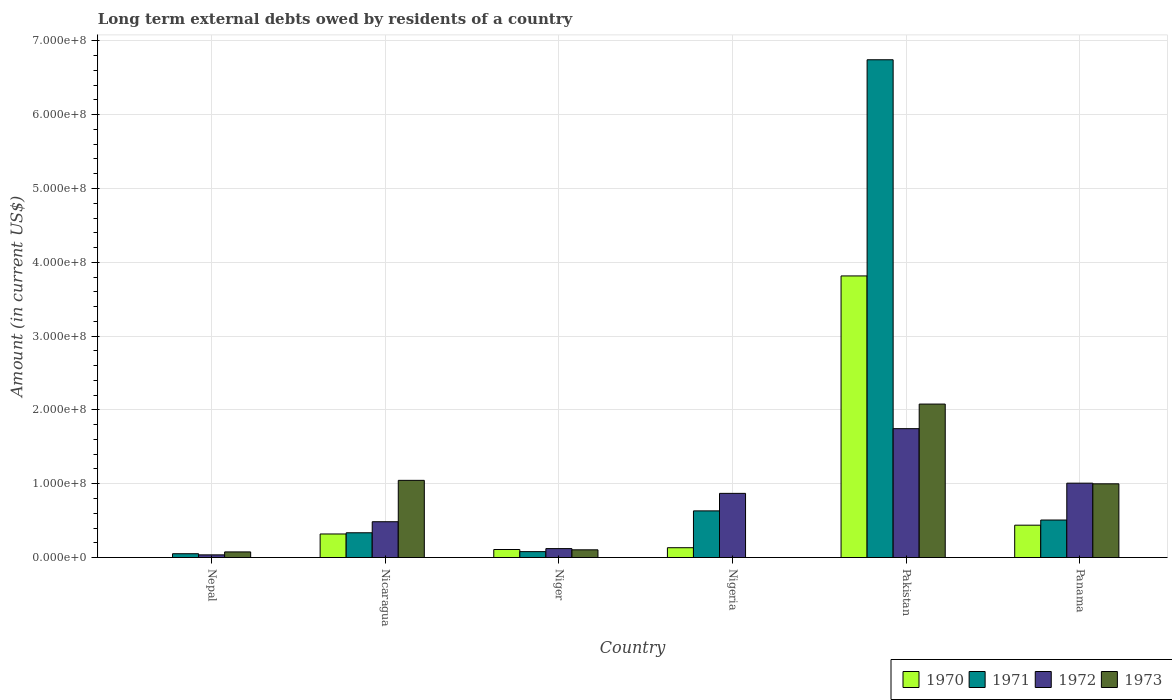How many different coloured bars are there?
Make the answer very short. 4. How many groups of bars are there?
Keep it short and to the point. 6. Are the number of bars per tick equal to the number of legend labels?
Keep it short and to the point. No. How many bars are there on the 1st tick from the left?
Ensure brevity in your answer.  3. How many bars are there on the 2nd tick from the right?
Make the answer very short. 4. What is the label of the 2nd group of bars from the left?
Keep it short and to the point. Nicaragua. In how many cases, is the number of bars for a given country not equal to the number of legend labels?
Provide a succinct answer. 2. What is the amount of long-term external debts owed by residents in 1973 in Nigeria?
Provide a succinct answer. 0. Across all countries, what is the maximum amount of long-term external debts owed by residents in 1973?
Offer a terse response. 2.08e+08. In which country was the amount of long-term external debts owed by residents in 1970 maximum?
Ensure brevity in your answer.  Pakistan. What is the total amount of long-term external debts owed by residents in 1971 in the graph?
Give a very brief answer. 8.35e+08. What is the difference between the amount of long-term external debts owed by residents in 1970 in Niger and that in Nigeria?
Your response must be concise. -2.44e+06. What is the difference between the amount of long-term external debts owed by residents in 1972 in Nepal and the amount of long-term external debts owed by residents in 1973 in Niger?
Offer a terse response. -6.84e+06. What is the average amount of long-term external debts owed by residents in 1973 per country?
Your answer should be compact. 7.17e+07. What is the difference between the amount of long-term external debts owed by residents of/in 1972 and amount of long-term external debts owed by residents of/in 1970 in Niger?
Your answer should be very brief. 1.23e+06. In how many countries, is the amount of long-term external debts owed by residents in 1971 greater than 380000000 US$?
Provide a succinct answer. 1. What is the ratio of the amount of long-term external debts owed by residents in 1972 in Nepal to that in Nigeria?
Make the answer very short. 0.04. Is the amount of long-term external debts owed by residents in 1973 in Nepal less than that in Pakistan?
Provide a succinct answer. Yes. Is the difference between the amount of long-term external debts owed by residents in 1972 in Nicaragua and Pakistan greater than the difference between the amount of long-term external debts owed by residents in 1970 in Nicaragua and Pakistan?
Provide a succinct answer. Yes. What is the difference between the highest and the second highest amount of long-term external debts owed by residents in 1970?
Offer a very short reply. 3.50e+08. What is the difference between the highest and the lowest amount of long-term external debts owed by residents in 1970?
Your answer should be compact. 3.82e+08. In how many countries, is the amount of long-term external debts owed by residents in 1970 greater than the average amount of long-term external debts owed by residents in 1970 taken over all countries?
Give a very brief answer. 1. Is it the case that in every country, the sum of the amount of long-term external debts owed by residents in 1970 and amount of long-term external debts owed by residents in 1973 is greater than the sum of amount of long-term external debts owed by residents in 1971 and amount of long-term external debts owed by residents in 1972?
Make the answer very short. No. Is it the case that in every country, the sum of the amount of long-term external debts owed by residents in 1970 and amount of long-term external debts owed by residents in 1972 is greater than the amount of long-term external debts owed by residents in 1971?
Provide a succinct answer. No. How many bars are there?
Give a very brief answer. 22. How many countries are there in the graph?
Make the answer very short. 6. What is the difference between two consecutive major ticks on the Y-axis?
Give a very brief answer. 1.00e+08. Are the values on the major ticks of Y-axis written in scientific E-notation?
Your answer should be very brief. Yes. Where does the legend appear in the graph?
Keep it short and to the point. Bottom right. How many legend labels are there?
Make the answer very short. 4. How are the legend labels stacked?
Your answer should be very brief. Horizontal. What is the title of the graph?
Offer a terse response. Long term external debts owed by residents of a country. Does "2003" appear as one of the legend labels in the graph?
Your answer should be very brief. No. What is the label or title of the X-axis?
Offer a very short reply. Country. What is the Amount (in current US$) in 1970 in Nepal?
Make the answer very short. 0. What is the Amount (in current US$) of 1971 in Nepal?
Offer a terse response. 5.15e+06. What is the Amount (in current US$) in 1972 in Nepal?
Offer a very short reply. 3.60e+06. What is the Amount (in current US$) of 1973 in Nepal?
Provide a short and direct response. 7.60e+06. What is the Amount (in current US$) of 1970 in Nicaragua?
Your answer should be compact. 3.19e+07. What is the Amount (in current US$) of 1971 in Nicaragua?
Give a very brief answer. 3.35e+07. What is the Amount (in current US$) in 1972 in Nicaragua?
Keep it short and to the point. 4.85e+07. What is the Amount (in current US$) of 1973 in Nicaragua?
Offer a very short reply. 1.05e+08. What is the Amount (in current US$) of 1970 in Niger?
Provide a succinct answer. 1.09e+07. What is the Amount (in current US$) in 1971 in Niger?
Provide a succinct answer. 8.00e+06. What is the Amount (in current US$) of 1972 in Niger?
Offer a terse response. 1.21e+07. What is the Amount (in current US$) in 1973 in Niger?
Provide a short and direct response. 1.04e+07. What is the Amount (in current US$) of 1970 in Nigeria?
Offer a very short reply. 1.33e+07. What is the Amount (in current US$) of 1971 in Nigeria?
Keep it short and to the point. 6.32e+07. What is the Amount (in current US$) of 1972 in Nigeria?
Your answer should be compact. 8.69e+07. What is the Amount (in current US$) in 1970 in Pakistan?
Provide a succinct answer. 3.82e+08. What is the Amount (in current US$) of 1971 in Pakistan?
Give a very brief answer. 6.74e+08. What is the Amount (in current US$) in 1972 in Pakistan?
Give a very brief answer. 1.75e+08. What is the Amount (in current US$) of 1973 in Pakistan?
Offer a very short reply. 2.08e+08. What is the Amount (in current US$) of 1970 in Panama?
Your answer should be very brief. 4.38e+07. What is the Amount (in current US$) in 1971 in Panama?
Keep it short and to the point. 5.08e+07. What is the Amount (in current US$) of 1972 in Panama?
Ensure brevity in your answer.  1.01e+08. What is the Amount (in current US$) in 1973 in Panama?
Provide a succinct answer. 9.99e+07. Across all countries, what is the maximum Amount (in current US$) of 1970?
Offer a very short reply. 3.82e+08. Across all countries, what is the maximum Amount (in current US$) of 1971?
Offer a very short reply. 6.74e+08. Across all countries, what is the maximum Amount (in current US$) in 1972?
Give a very brief answer. 1.75e+08. Across all countries, what is the maximum Amount (in current US$) of 1973?
Make the answer very short. 2.08e+08. Across all countries, what is the minimum Amount (in current US$) in 1970?
Your response must be concise. 0. Across all countries, what is the minimum Amount (in current US$) of 1971?
Offer a very short reply. 5.15e+06. Across all countries, what is the minimum Amount (in current US$) in 1972?
Make the answer very short. 3.60e+06. What is the total Amount (in current US$) in 1970 in the graph?
Provide a short and direct response. 4.81e+08. What is the total Amount (in current US$) in 1971 in the graph?
Make the answer very short. 8.35e+08. What is the total Amount (in current US$) in 1972 in the graph?
Your answer should be very brief. 4.26e+08. What is the total Amount (in current US$) in 1973 in the graph?
Make the answer very short. 4.30e+08. What is the difference between the Amount (in current US$) of 1971 in Nepal and that in Nicaragua?
Your response must be concise. -2.84e+07. What is the difference between the Amount (in current US$) in 1972 in Nepal and that in Nicaragua?
Make the answer very short. -4.49e+07. What is the difference between the Amount (in current US$) in 1973 in Nepal and that in Nicaragua?
Ensure brevity in your answer.  -9.70e+07. What is the difference between the Amount (in current US$) of 1971 in Nepal and that in Niger?
Ensure brevity in your answer.  -2.85e+06. What is the difference between the Amount (in current US$) of 1972 in Nepal and that in Niger?
Provide a succinct answer. -8.48e+06. What is the difference between the Amount (in current US$) of 1973 in Nepal and that in Niger?
Offer a terse response. -2.84e+06. What is the difference between the Amount (in current US$) in 1971 in Nepal and that in Nigeria?
Give a very brief answer. -5.81e+07. What is the difference between the Amount (in current US$) of 1972 in Nepal and that in Nigeria?
Provide a succinct answer. -8.33e+07. What is the difference between the Amount (in current US$) of 1971 in Nepal and that in Pakistan?
Your answer should be very brief. -6.69e+08. What is the difference between the Amount (in current US$) of 1972 in Nepal and that in Pakistan?
Keep it short and to the point. -1.71e+08. What is the difference between the Amount (in current US$) of 1973 in Nepal and that in Pakistan?
Give a very brief answer. -2.00e+08. What is the difference between the Amount (in current US$) in 1971 in Nepal and that in Panama?
Provide a succinct answer. -4.57e+07. What is the difference between the Amount (in current US$) of 1972 in Nepal and that in Panama?
Provide a succinct answer. -9.72e+07. What is the difference between the Amount (in current US$) in 1973 in Nepal and that in Panama?
Your answer should be very brief. -9.23e+07. What is the difference between the Amount (in current US$) of 1970 in Nicaragua and that in Niger?
Offer a very short reply. 2.10e+07. What is the difference between the Amount (in current US$) of 1971 in Nicaragua and that in Niger?
Your answer should be compact. 2.55e+07. What is the difference between the Amount (in current US$) of 1972 in Nicaragua and that in Niger?
Ensure brevity in your answer.  3.64e+07. What is the difference between the Amount (in current US$) of 1973 in Nicaragua and that in Niger?
Provide a short and direct response. 9.41e+07. What is the difference between the Amount (in current US$) of 1970 in Nicaragua and that in Nigeria?
Your response must be concise. 1.86e+07. What is the difference between the Amount (in current US$) of 1971 in Nicaragua and that in Nigeria?
Your answer should be very brief. -2.97e+07. What is the difference between the Amount (in current US$) in 1972 in Nicaragua and that in Nigeria?
Provide a short and direct response. -3.84e+07. What is the difference between the Amount (in current US$) of 1970 in Nicaragua and that in Pakistan?
Your answer should be compact. -3.50e+08. What is the difference between the Amount (in current US$) in 1971 in Nicaragua and that in Pakistan?
Provide a short and direct response. -6.41e+08. What is the difference between the Amount (in current US$) in 1972 in Nicaragua and that in Pakistan?
Your answer should be very brief. -1.26e+08. What is the difference between the Amount (in current US$) of 1973 in Nicaragua and that in Pakistan?
Offer a very short reply. -1.03e+08. What is the difference between the Amount (in current US$) in 1970 in Nicaragua and that in Panama?
Offer a very short reply. -1.19e+07. What is the difference between the Amount (in current US$) in 1971 in Nicaragua and that in Panama?
Ensure brevity in your answer.  -1.73e+07. What is the difference between the Amount (in current US$) in 1972 in Nicaragua and that in Panama?
Ensure brevity in your answer.  -5.23e+07. What is the difference between the Amount (in current US$) of 1973 in Nicaragua and that in Panama?
Give a very brief answer. 4.71e+06. What is the difference between the Amount (in current US$) in 1970 in Niger and that in Nigeria?
Provide a succinct answer. -2.44e+06. What is the difference between the Amount (in current US$) in 1971 in Niger and that in Nigeria?
Give a very brief answer. -5.52e+07. What is the difference between the Amount (in current US$) of 1972 in Niger and that in Nigeria?
Your answer should be very brief. -7.48e+07. What is the difference between the Amount (in current US$) of 1970 in Niger and that in Pakistan?
Ensure brevity in your answer.  -3.71e+08. What is the difference between the Amount (in current US$) of 1971 in Niger and that in Pakistan?
Offer a terse response. -6.66e+08. What is the difference between the Amount (in current US$) of 1972 in Niger and that in Pakistan?
Offer a very short reply. -1.63e+08. What is the difference between the Amount (in current US$) in 1973 in Niger and that in Pakistan?
Your answer should be compact. -1.97e+08. What is the difference between the Amount (in current US$) of 1970 in Niger and that in Panama?
Make the answer very short. -3.30e+07. What is the difference between the Amount (in current US$) of 1971 in Niger and that in Panama?
Offer a terse response. -4.28e+07. What is the difference between the Amount (in current US$) of 1972 in Niger and that in Panama?
Make the answer very short. -8.87e+07. What is the difference between the Amount (in current US$) of 1973 in Niger and that in Panama?
Offer a terse response. -8.94e+07. What is the difference between the Amount (in current US$) of 1970 in Nigeria and that in Pakistan?
Give a very brief answer. -3.68e+08. What is the difference between the Amount (in current US$) of 1971 in Nigeria and that in Pakistan?
Ensure brevity in your answer.  -6.11e+08. What is the difference between the Amount (in current US$) of 1972 in Nigeria and that in Pakistan?
Your answer should be compact. -8.77e+07. What is the difference between the Amount (in current US$) of 1970 in Nigeria and that in Panama?
Your answer should be very brief. -3.05e+07. What is the difference between the Amount (in current US$) of 1971 in Nigeria and that in Panama?
Make the answer very short. 1.24e+07. What is the difference between the Amount (in current US$) in 1972 in Nigeria and that in Panama?
Your answer should be very brief. -1.38e+07. What is the difference between the Amount (in current US$) in 1970 in Pakistan and that in Panama?
Keep it short and to the point. 3.38e+08. What is the difference between the Amount (in current US$) in 1971 in Pakistan and that in Panama?
Provide a short and direct response. 6.24e+08. What is the difference between the Amount (in current US$) of 1972 in Pakistan and that in Panama?
Keep it short and to the point. 7.38e+07. What is the difference between the Amount (in current US$) of 1973 in Pakistan and that in Panama?
Provide a succinct answer. 1.08e+08. What is the difference between the Amount (in current US$) in 1971 in Nepal and the Amount (in current US$) in 1972 in Nicaragua?
Provide a succinct answer. -4.34e+07. What is the difference between the Amount (in current US$) in 1971 in Nepal and the Amount (in current US$) in 1973 in Nicaragua?
Your answer should be compact. -9.94e+07. What is the difference between the Amount (in current US$) in 1972 in Nepal and the Amount (in current US$) in 1973 in Nicaragua?
Your response must be concise. -1.01e+08. What is the difference between the Amount (in current US$) of 1971 in Nepal and the Amount (in current US$) of 1972 in Niger?
Your answer should be compact. -6.94e+06. What is the difference between the Amount (in current US$) of 1971 in Nepal and the Amount (in current US$) of 1973 in Niger?
Your response must be concise. -5.30e+06. What is the difference between the Amount (in current US$) in 1972 in Nepal and the Amount (in current US$) in 1973 in Niger?
Provide a short and direct response. -6.84e+06. What is the difference between the Amount (in current US$) in 1971 in Nepal and the Amount (in current US$) in 1972 in Nigeria?
Your answer should be compact. -8.18e+07. What is the difference between the Amount (in current US$) in 1971 in Nepal and the Amount (in current US$) in 1972 in Pakistan?
Ensure brevity in your answer.  -1.69e+08. What is the difference between the Amount (in current US$) in 1971 in Nepal and the Amount (in current US$) in 1973 in Pakistan?
Make the answer very short. -2.03e+08. What is the difference between the Amount (in current US$) of 1972 in Nepal and the Amount (in current US$) of 1973 in Pakistan?
Keep it short and to the point. -2.04e+08. What is the difference between the Amount (in current US$) of 1971 in Nepal and the Amount (in current US$) of 1972 in Panama?
Your answer should be very brief. -9.56e+07. What is the difference between the Amount (in current US$) of 1971 in Nepal and the Amount (in current US$) of 1973 in Panama?
Keep it short and to the point. -9.47e+07. What is the difference between the Amount (in current US$) of 1972 in Nepal and the Amount (in current US$) of 1973 in Panama?
Your answer should be very brief. -9.63e+07. What is the difference between the Amount (in current US$) in 1970 in Nicaragua and the Amount (in current US$) in 1971 in Niger?
Keep it short and to the point. 2.39e+07. What is the difference between the Amount (in current US$) of 1970 in Nicaragua and the Amount (in current US$) of 1972 in Niger?
Offer a very short reply. 1.98e+07. What is the difference between the Amount (in current US$) in 1970 in Nicaragua and the Amount (in current US$) in 1973 in Niger?
Make the answer very short. 2.15e+07. What is the difference between the Amount (in current US$) of 1971 in Nicaragua and the Amount (in current US$) of 1972 in Niger?
Your answer should be compact. 2.14e+07. What is the difference between the Amount (in current US$) of 1971 in Nicaragua and the Amount (in current US$) of 1973 in Niger?
Ensure brevity in your answer.  2.31e+07. What is the difference between the Amount (in current US$) of 1972 in Nicaragua and the Amount (in current US$) of 1973 in Niger?
Provide a short and direct response. 3.81e+07. What is the difference between the Amount (in current US$) in 1970 in Nicaragua and the Amount (in current US$) in 1971 in Nigeria?
Make the answer very short. -3.13e+07. What is the difference between the Amount (in current US$) in 1970 in Nicaragua and the Amount (in current US$) in 1972 in Nigeria?
Offer a terse response. -5.50e+07. What is the difference between the Amount (in current US$) of 1971 in Nicaragua and the Amount (in current US$) of 1972 in Nigeria?
Make the answer very short. -5.34e+07. What is the difference between the Amount (in current US$) of 1970 in Nicaragua and the Amount (in current US$) of 1971 in Pakistan?
Provide a succinct answer. -6.43e+08. What is the difference between the Amount (in current US$) in 1970 in Nicaragua and the Amount (in current US$) in 1972 in Pakistan?
Your response must be concise. -1.43e+08. What is the difference between the Amount (in current US$) of 1970 in Nicaragua and the Amount (in current US$) of 1973 in Pakistan?
Provide a short and direct response. -1.76e+08. What is the difference between the Amount (in current US$) of 1971 in Nicaragua and the Amount (in current US$) of 1972 in Pakistan?
Keep it short and to the point. -1.41e+08. What is the difference between the Amount (in current US$) of 1971 in Nicaragua and the Amount (in current US$) of 1973 in Pakistan?
Keep it short and to the point. -1.74e+08. What is the difference between the Amount (in current US$) of 1972 in Nicaragua and the Amount (in current US$) of 1973 in Pakistan?
Make the answer very short. -1.59e+08. What is the difference between the Amount (in current US$) in 1970 in Nicaragua and the Amount (in current US$) in 1971 in Panama?
Provide a succinct answer. -1.89e+07. What is the difference between the Amount (in current US$) of 1970 in Nicaragua and the Amount (in current US$) of 1972 in Panama?
Make the answer very short. -6.89e+07. What is the difference between the Amount (in current US$) of 1970 in Nicaragua and the Amount (in current US$) of 1973 in Panama?
Your response must be concise. -6.80e+07. What is the difference between the Amount (in current US$) in 1971 in Nicaragua and the Amount (in current US$) in 1972 in Panama?
Give a very brief answer. -6.72e+07. What is the difference between the Amount (in current US$) in 1971 in Nicaragua and the Amount (in current US$) in 1973 in Panama?
Offer a terse response. -6.63e+07. What is the difference between the Amount (in current US$) of 1972 in Nicaragua and the Amount (in current US$) of 1973 in Panama?
Offer a terse response. -5.14e+07. What is the difference between the Amount (in current US$) of 1970 in Niger and the Amount (in current US$) of 1971 in Nigeria?
Keep it short and to the point. -5.24e+07. What is the difference between the Amount (in current US$) in 1970 in Niger and the Amount (in current US$) in 1972 in Nigeria?
Your response must be concise. -7.61e+07. What is the difference between the Amount (in current US$) in 1971 in Niger and the Amount (in current US$) in 1972 in Nigeria?
Your answer should be very brief. -7.89e+07. What is the difference between the Amount (in current US$) of 1970 in Niger and the Amount (in current US$) of 1971 in Pakistan?
Your response must be concise. -6.64e+08. What is the difference between the Amount (in current US$) in 1970 in Niger and the Amount (in current US$) in 1972 in Pakistan?
Ensure brevity in your answer.  -1.64e+08. What is the difference between the Amount (in current US$) of 1970 in Niger and the Amount (in current US$) of 1973 in Pakistan?
Keep it short and to the point. -1.97e+08. What is the difference between the Amount (in current US$) of 1971 in Niger and the Amount (in current US$) of 1972 in Pakistan?
Offer a terse response. -1.67e+08. What is the difference between the Amount (in current US$) in 1971 in Niger and the Amount (in current US$) in 1973 in Pakistan?
Provide a short and direct response. -2.00e+08. What is the difference between the Amount (in current US$) of 1972 in Niger and the Amount (in current US$) of 1973 in Pakistan?
Provide a short and direct response. -1.96e+08. What is the difference between the Amount (in current US$) of 1970 in Niger and the Amount (in current US$) of 1971 in Panama?
Ensure brevity in your answer.  -4.00e+07. What is the difference between the Amount (in current US$) of 1970 in Niger and the Amount (in current US$) of 1972 in Panama?
Offer a terse response. -8.99e+07. What is the difference between the Amount (in current US$) of 1970 in Niger and the Amount (in current US$) of 1973 in Panama?
Offer a very short reply. -8.90e+07. What is the difference between the Amount (in current US$) of 1971 in Niger and the Amount (in current US$) of 1972 in Panama?
Your response must be concise. -9.28e+07. What is the difference between the Amount (in current US$) in 1971 in Niger and the Amount (in current US$) in 1973 in Panama?
Your answer should be very brief. -9.19e+07. What is the difference between the Amount (in current US$) in 1972 in Niger and the Amount (in current US$) in 1973 in Panama?
Your answer should be very brief. -8.78e+07. What is the difference between the Amount (in current US$) of 1970 in Nigeria and the Amount (in current US$) of 1971 in Pakistan?
Your answer should be very brief. -6.61e+08. What is the difference between the Amount (in current US$) of 1970 in Nigeria and the Amount (in current US$) of 1972 in Pakistan?
Offer a very short reply. -1.61e+08. What is the difference between the Amount (in current US$) of 1970 in Nigeria and the Amount (in current US$) of 1973 in Pakistan?
Make the answer very short. -1.95e+08. What is the difference between the Amount (in current US$) in 1971 in Nigeria and the Amount (in current US$) in 1972 in Pakistan?
Provide a succinct answer. -1.11e+08. What is the difference between the Amount (in current US$) of 1971 in Nigeria and the Amount (in current US$) of 1973 in Pakistan?
Offer a terse response. -1.45e+08. What is the difference between the Amount (in current US$) of 1972 in Nigeria and the Amount (in current US$) of 1973 in Pakistan?
Your answer should be compact. -1.21e+08. What is the difference between the Amount (in current US$) of 1970 in Nigeria and the Amount (in current US$) of 1971 in Panama?
Your answer should be very brief. -3.75e+07. What is the difference between the Amount (in current US$) in 1970 in Nigeria and the Amount (in current US$) in 1972 in Panama?
Provide a succinct answer. -8.75e+07. What is the difference between the Amount (in current US$) of 1970 in Nigeria and the Amount (in current US$) of 1973 in Panama?
Your answer should be very brief. -8.66e+07. What is the difference between the Amount (in current US$) in 1971 in Nigeria and the Amount (in current US$) in 1972 in Panama?
Ensure brevity in your answer.  -3.76e+07. What is the difference between the Amount (in current US$) of 1971 in Nigeria and the Amount (in current US$) of 1973 in Panama?
Provide a short and direct response. -3.67e+07. What is the difference between the Amount (in current US$) in 1972 in Nigeria and the Amount (in current US$) in 1973 in Panama?
Offer a very short reply. -1.29e+07. What is the difference between the Amount (in current US$) of 1970 in Pakistan and the Amount (in current US$) of 1971 in Panama?
Your response must be concise. 3.31e+08. What is the difference between the Amount (in current US$) of 1970 in Pakistan and the Amount (in current US$) of 1972 in Panama?
Make the answer very short. 2.81e+08. What is the difference between the Amount (in current US$) in 1970 in Pakistan and the Amount (in current US$) in 1973 in Panama?
Make the answer very short. 2.82e+08. What is the difference between the Amount (in current US$) of 1971 in Pakistan and the Amount (in current US$) of 1972 in Panama?
Keep it short and to the point. 5.74e+08. What is the difference between the Amount (in current US$) in 1971 in Pakistan and the Amount (in current US$) in 1973 in Panama?
Ensure brevity in your answer.  5.75e+08. What is the difference between the Amount (in current US$) of 1972 in Pakistan and the Amount (in current US$) of 1973 in Panama?
Provide a succinct answer. 7.47e+07. What is the average Amount (in current US$) in 1970 per country?
Your response must be concise. 8.02e+07. What is the average Amount (in current US$) in 1971 per country?
Ensure brevity in your answer.  1.39e+08. What is the average Amount (in current US$) in 1972 per country?
Offer a terse response. 7.11e+07. What is the average Amount (in current US$) in 1973 per country?
Your answer should be very brief. 7.17e+07. What is the difference between the Amount (in current US$) of 1971 and Amount (in current US$) of 1972 in Nepal?
Your answer should be compact. 1.54e+06. What is the difference between the Amount (in current US$) of 1971 and Amount (in current US$) of 1973 in Nepal?
Provide a short and direct response. -2.46e+06. What is the difference between the Amount (in current US$) in 1972 and Amount (in current US$) in 1973 in Nepal?
Offer a terse response. -4.00e+06. What is the difference between the Amount (in current US$) of 1970 and Amount (in current US$) of 1971 in Nicaragua?
Offer a very short reply. -1.63e+06. What is the difference between the Amount (in current US$) of 1970 and Amount (in current US$) of 1972 in Nicaragua?
Provide a succinct answer. -1.66e+07. What is the difference between the Amount (in current US$) of 1970 and Amount (in current US$) of 1973 in Nicaragua?
Offer a very short reply. -7.27e+07. What is the difference between the Amount (in current US$) in 1971 and Amount (in current US$) in 1972 in Nicaragua?
Provide a succinct answer. -1.50e+07. What is the difference between the Amount (in current US$) of 1971 and Amount (in current US$) of 1973 in Nicaragua?
Give a very brief answer. -7.10e+07. What is the difference between the Amount (in current US$) of 1972 and Amount (in current US$) of 1973 in Nicaragua?
Keep it short and to the point. -5.61e+07. What is the difference between the Amount (in current US$) in 1970 and Amount (in current US$) in 1971 in Niger?
Provide a succinct answer. 2.86e+06. What is the difference between the Amount (in current US$) in 1970 and Amount (in current US$) in 1972 in Niger?
Provide a short and direct response. -1.23e+06. What is the difference between the Amount (in current US$) in 1970 and Amount (in current US$) in 1973 in Niger?
Offer a terse response. 4.08e+05. What is the difference between the Amount (in current US$) in 1971 and Amount (in current US$) in 1972 in Niger?
Your answer should be compact. -4.09e+06. What is the difference between the Amount (in current US$) of 1971 and Amount (in current US$) of 1973 in Niger?
Keep it short and to the point. -2.45e+06. What is the difference between the Amount (in current US$) in 1972 and Amount (in current US$) in 1973 in Niger?
Offer a very short reply. 1.64e+06. What is the difference between the Amount (in current US$) of 1970 and Amount (in current US$) of 1971 in Nigeria?
Provide a short and direct response. -4.99e+07. What is the difference between the Amount (in current US$) in 1970 and Amount (in current US$) in 1972 in Nigeria?
Offer a very short reply. -7.36e+07. What is the difference between the Amount (in current US$) of 1971 and Amount (in current US$) of 1972 in Nigeria?
Make the answer very short. -2.37e+07. What is the difference between the Amount (in current US$) of 1970 and Amount (in current US$) of 1971 in Pakistan?
Ensure brevity in your answer.  -2.93e+08. What is the difference between the Amount (in current US$) in 1970 and Amount (in current US$) in 1972 in Pakistan?
Provide a short and direct response. 2.07e+08. What is the difference between the Amount (in current US$) in 1970 and Amount (in current US$) in 1973 in Pakistan?
Keep it short and to the point. 1.74e+08. What is the difference between the Amount (in current US$) of 1971 and Amount (in current US$) of 1972 in Pakistan?
Keep it short and to the point. 5.00e+08. What is the difference between the Amount (in current US$) in 1971 and Amount (in current US$) in 1973 in Pakistan?
Your answer should be compact. 4.67e+08. What is the difference between the Amount (in current US$) of 1972 and Amount (in current US$) of 1973 in Pakistan?
Your answer should be very brief. -3.33e+07. What is the difference between the Amount (in current US$) in 1970 and Amount (in current US$) in 1971 in Panama?
Ensure brevity in your answer.  -6.98e+06. What is the difference between the Amount (in current US$) in 1970 and Amount (in current US$) in 1972 in Panama?
Keep it short and to the point. -5.69e+07. What is the difference between the Amount (in current US$) of 1970 and Amount (in current US$) of 1973 in Panama?
Your answer should be compact. -5.60e+07. What is the difference between the Amount (in current US$) in 1971 and Amount (in current US$) in 1972 in Panama?
Give a very brief answer. -5.00e+07. What is the difference between the Amount (in current US$) in 1971 and Amount (in current US$) in 1973 in Panama?
Make the answer very short. -4.90e+07. What is the difference between the Amount (in current US$) of 1972 and Amount (in current US$) of 1973 in Panama?
Your answer should be compact. 9.03e+05. What is the ratio of the Amount (in current US$) in 1971 in Nepal to that in Nicaragua?
Make the answer very short. 0.15. What is the ratio of the Amount (in current US$) in 1972 in Nepal to that in Nicaragua?
Your answer should be very brief. 0.07. What is the ratio of the Amount (in current US$) of 1973 in Nepal to that in Nicaragua?
Ensure brevity in your answer.  0.07. What is the ratio of the Amount (in current US$) in 1971 in Nepal to that in Niger?
Keep it short and to the point. 0.64. What is the ratio of the Amount (in current US$) in 1972 in Nepal to that in Niger?
Keep it short and to the point. 0.3. What is the ratio of the Amount (in current US$) in 1973 in Nepal to that in Niger?
Give a very brief answer. 0.73. What is the ratio of the Amount (in current US$) of 1971 in Nepal to that in Nigeria?
Offer a very short reply. 0.08. What is the ratio of the Amount (in current US$) of 1972 in Nepal to that in Nigeria?
Your answer should be very brief. 0.04. What is the ratio of the Amount (in current US$) in 1971 in Nepal to that in Pakistan?
Make the answer very short. 0.01. What is the ratio of the Amount (in current US$) of 1972 in Nepal to that in Pakistan?
Keep it short and to the point. 0.02. What is the ratio of the Amount (in current US$) in 1973 in Nepal to that in Pakistan?
Make the answer very short. 0.04. What is the ratio of the Amount (in current US$) of 1971 in Nepal to that in Panama?
Your response must be concise. 0.1. What is the ratio of the Amount (in current US$) of 1972 in Nepal to that in Panama?
Your answer should be very brief. 0.04. What is the ratio of the Amount (in current US$) of 1973 in Nepal to that in Panama?
Give a very brief answer. 0.08. What is the ratio of the Amount (in current US$) in 1970 in Nicaragua to that in Niger?
Your response must be concise. 2.94. What is the ratio of the Amount (in current US$) in 1971 in Nicaragua to that in Niger?
Provide a short and direct response. 4.19. What is the ratio of the Amount (in current US$) of 1972 in Nicaragua to that in Niger?
Ensure brevity in your answer.  4.01. What is the ratio of the Amount (in current US$) in 1973 in Nicaragua to that in Niger?
Offer a very short reply. 10.01. What is the ratio of the Amount (in current US$) of 1970 in Nicaragua to that in Nigeria?
Make the answer very short. 2.4. What is the ratio of the Amount (in current US$) in 1971 in Nicaragua to that in Nigeria?
Provide a succinct answer. 0.53. What is the ratio of the Amount (in current US$) of 1972 in Nicaragua to that in Nigeria?
Provide a short and direct response. 0.56. What is the ratio of the Amount (in current US$) of 1970 in Nicaragua to that in Pakistan?
Ensure brevity in your answer.  0.08. What is the ratio of the Amount (in current US$) of 1971 in Nicaragua to that in Pakistan?
Offer a terse response. 0.05. What is the ratio of the Amount (in current US$) of 1972 in Nicaragua to that in Pakistan?
Your response must be concise. 0.28. What is the ratio of the Amount (in current US$) of 1973 in Nicaragua to that in Pakistan?
Your response must be concise. 0.5. What is the ratio of the Amount (in current US$) in 1970 in Nicaragua to that in Panama?
Your response must be concise. 0.73. What is the ratio of the Amount (in current US$) in 1971 in Nicaragua to that in Panama?
Offer a terse response. 0.66. What is the ratio of the Amount (in current US$) of 1972 in Nicaragua to that in Panama?
Ensure brevity in your answer.  0.48. What is the ratio of the Amount (in current US$) of 1973 in Nicaragua to that in Panama?
Provide a short and direct response. 1.05. What is the ratio of the Amount (in current US$) in 1970 in Niger to that in Nigeria?
Offer a very short reply. 0.82. What is the ratio of the Amount (in current US$) of 1971 in Niger to that in Nigeria?
Make the answer very short. 0.13. What is the ratio of the Amount (in current US$) of 1972 in Niger to that in Nigeria?
Your answer should be very brief. 0.14. What is the ratio of the Amount (in current US$) in 1970 in Niger to that in Pakistan?
Your answer should be compact. 0.03. What is the ratio of the Amount (in current US$) in 1971 in Niger to that in Pakistan?
Ensure brevity in your answer.  0.01. What is the ratio of the Amount (in current US$) of 1972 in Niger to that in Pakistan?
Your response must be concise. 0.07. What is the ratio of the Amount (in current US$) in 1973 in Niger to that in Pakistan?
Give a very brief answer. 0.05. What is the ratio of the Amount (in current US$) in 1970 in Niger to that in Panama?
Offer a very short reply. 0.25. What is the ratio of the Amount (in current US$) of 1971 in Niger to that in Panama?
Provide a short and direct response. 0.16. What is the ratio of the Amount (in current US$) in 1972 in Niger to that in Panama?
Offer a terse response. 0.12. What is the ratio of the Amount (in current US$) of 1973 in Niger to that in Panama?
Your response must be concise. 0.1. What is the ratio of the Amount (in current US$) in 1970 in Nigeria to that in Pakistan?
Give a very brief answer. 0.03. What is the ratio of the Amount (in current US$) in 1971 in Nigeria to that in Pakistan?
Keep it short and to the point. 0.09. What is the ratio of the Amount (in current US$) of 1972 in Nigeria to that in Pakistan?
Make the answer very short. 0.5. What is the ratio of the Amount (in current US$) of 1970 in Nigeria to that in Panama?
Ensure brevity in your answer.  0.3. What is the ratio of the Amount (in current US$) in 1971 in Nigeria to that in Panama?
Provide a short and direct response. 1.24. What is the ratio of the Amount (in current US$) of 1972 in Nigeria to that in Panama?
Provide a succinct answer. 0.86. What is the ratio of the Amount (in current US$) of 1970 in Pakistan to that in Panama?
Your answer should be compact. 8.7. What is the ratio of the Amount (in current US$) in 1971 in Pakistan to that in Panama?
Make the answer very short. 13.27. What is the ratio of the Amount (in current US$) of 1972 in Pakistan to that in Panama?
Your response must be concise. 1.73. What is the ratio of the Amount (in current US$) of 1973 in Pakistan to that in Panama?
Your answer should be very brief. 2.08. What is the difference between the highest and the second highest Amount (in current US$) in 1970?
Provide a succinct answer. 3.38e+08. What is the difference between the highest and the second highest Amount (in current US$) of 1971?
Provide a short and direct response. 6.11e+08. What is the difference between the highest and the second highest Amount (in current US$) in 1972?
Provide a short and direct response. 7.38e+07. What is the difference between the highest and the second highest Amount (in current US$) in 1973?
Provide a succinct answer. 1.03e+08. What is the difference between the highest and the lowest Amount (in current US$) of 1970?
Provide a succinct answer. 3.82e+08. What is the difference between the highest and the lowest Amount (in current US$) of 1971?
Your answer should be compact. 6.69e+08. What is the difference between the highest and the lowest Amount (in current US$) of 1972?
Give a very brief answer. 1.71e+08. What is the difference between the highest and the lowest Amount (in current US$) of 1973?
Provide a short and direct response. 2.08e+08. 